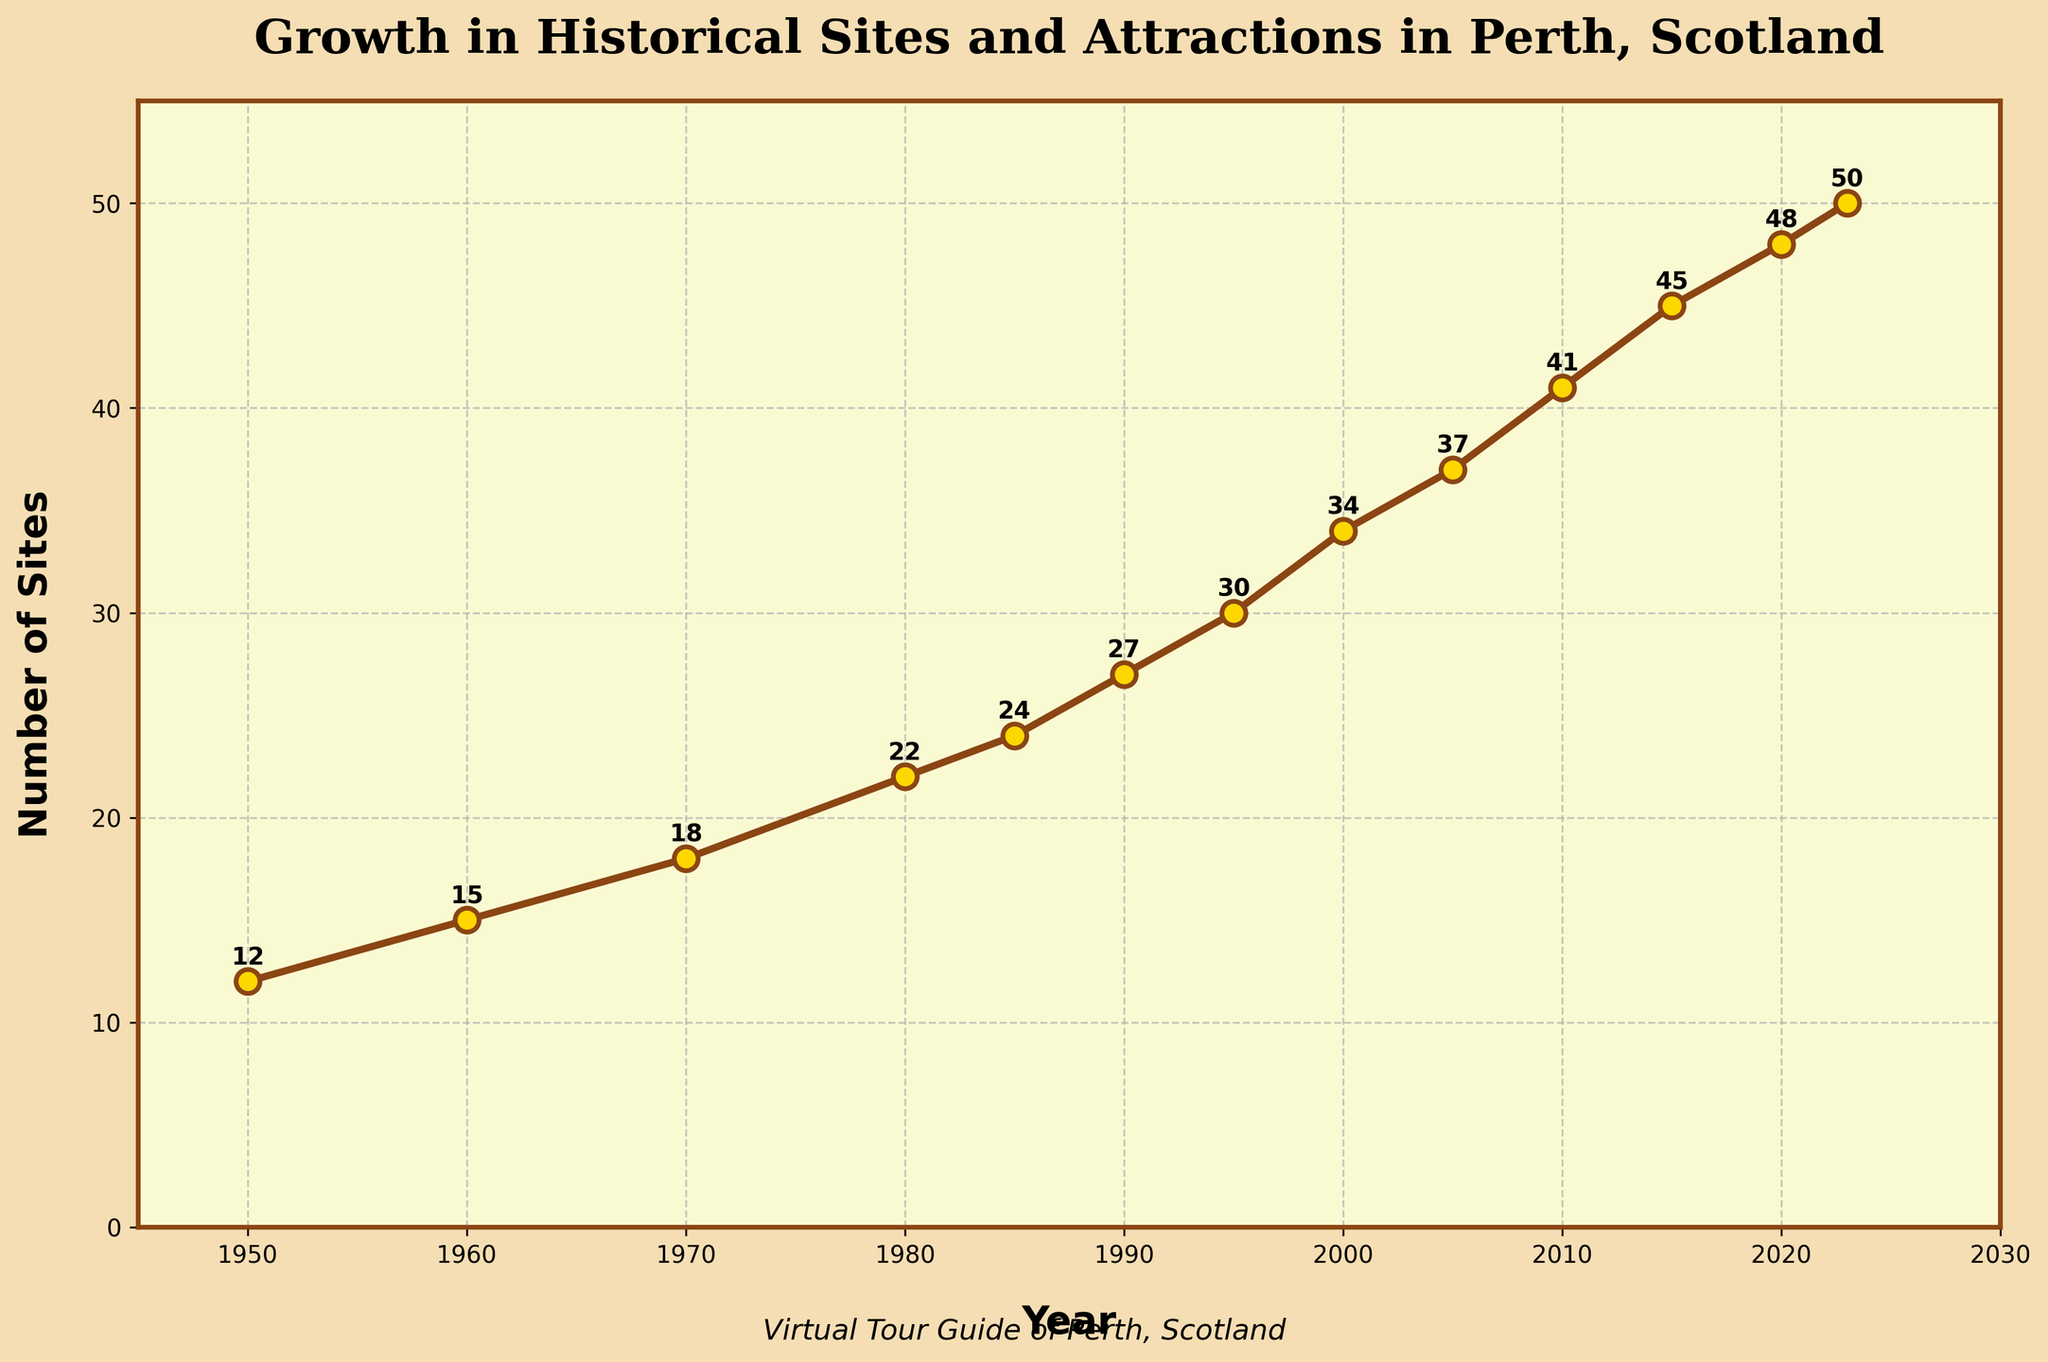How many historical sites were recorded in 1970? Look for the data point corresponding to the year 1970. The figure shows the number of historical sites was 18.
Answer: 18 Which decade experienced the greatest increase in the number of historical sites? Compare the increase in the number of sites between each decade. The decade from 2000 to 2010 shows the largest increase (34 to 41, an increase of 7).
Answer: 2000 to 2010 By how much did the number of historical sites increase from 1950 to 2023? Subtract the number of historical sites in 1950 from the number in 2023: 50 - 12 = 38.
Answer: 38 What is the average number of historical sites for the years 1950, 1980, and 2010? Add the values for the years 1950, 1980, and 2010, then divide by 3: (12 + 22 + 41) / 3 = 75 / 3 = 25.
Answer: 25 In which year did the number of historical sites reach 30? Identify the year when the number of sites is shown as 30 in the figure, which is 1995.
Answer: 1995 How many times did the number of historical sites increase by more than 5 within a decade? Examine each decade and count the number of times the increase is more than 5. The increases occur in the decades from 1990 to 2000 (27 to 34) and from 2000 to 2010 (34 to 41), so it happens twice.
Answer: 2 Is there a year when the number of historical sites did not increase? Check the data points; the number of historical sites increases in every recorded year.
Answer: No What is the median number of historical sites from the data given? The median is the middle value of the sorted number of historical sites. Sorting the given values and selecting the middle value: (12, 15, 18, 22, 24, 27, 30, 34, 37, 41, 45, 48, 50). The median value is 30.
Answer: 30 Which year had an equal number of historical sites as the difference between the figures for 2023 and 2005? Calculate the difference: 50 (2023) - 37 (2005) = 13. No year in the data shows exactly 13 historical sites.
Answer: None What is the visual color theme used in the plot for the line and markers? The line is brown, markers have a golden color with brown edges, and the background is a yellowish-cream color.
Answer: Brown and golden with yellowish-cream background 